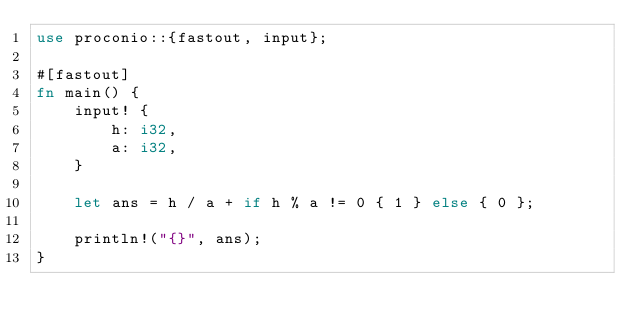<code> <loc_0><loc_0><loc_500><loc_500><_Rust_>use proconio::{fastout, input};

#[fastout]
fn main() {
    input! {
        h: i32,
        a: i32,
    }

    let ans = h / a + if h % a != 0 { 1 } else { 0 };

    println!("{}", ans);
}
</code> 